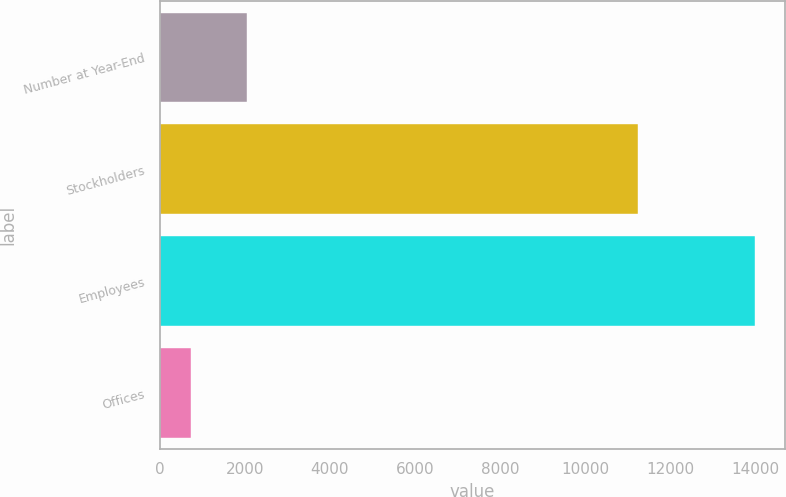Convert chart. <chart><loc_0><loc_0><loc_500><loc_500><bar_chart><fcel>Number at Year-End<fcel>Stockholders<fcel>Employees<fcel>Offices<nl><fcel>2061.5<fcel>11258<fcel>14000<fcel>735<nl></chart> 